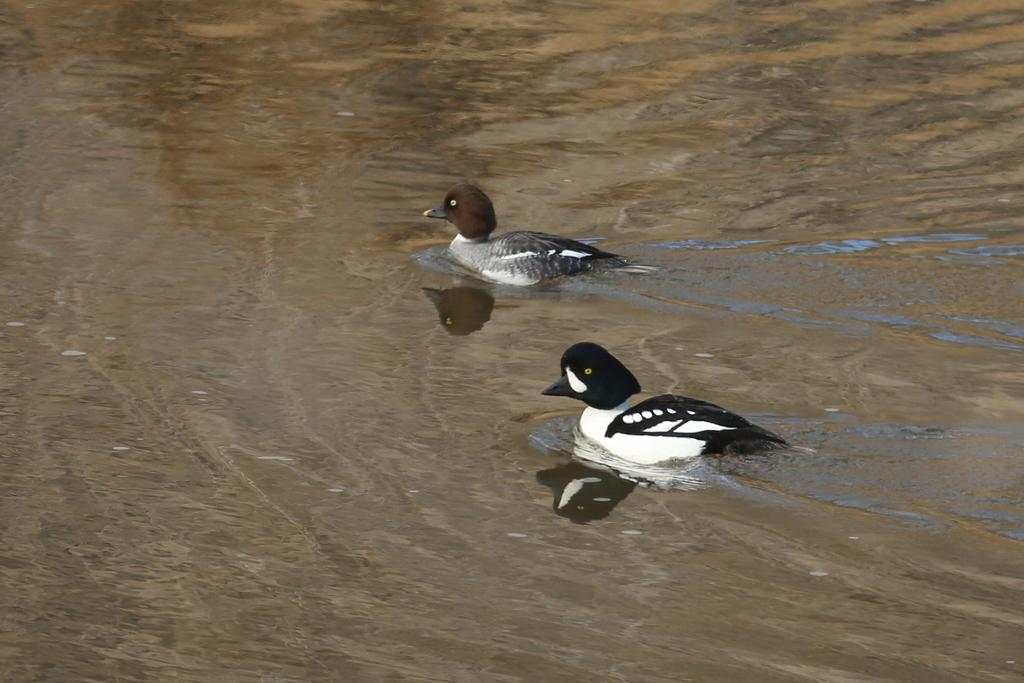What is visible in the image? Water is visible in the image. What can be seen on the water? There are two birds on the water. What type of oranges can be seen floating in the water? There are no oranges present in the image; it features water and two birds. What substance is the water made of in the image? The substance that the water is made of is not mentioned in the image, but it is likely to be H2O, which is the chemical formula for water. 